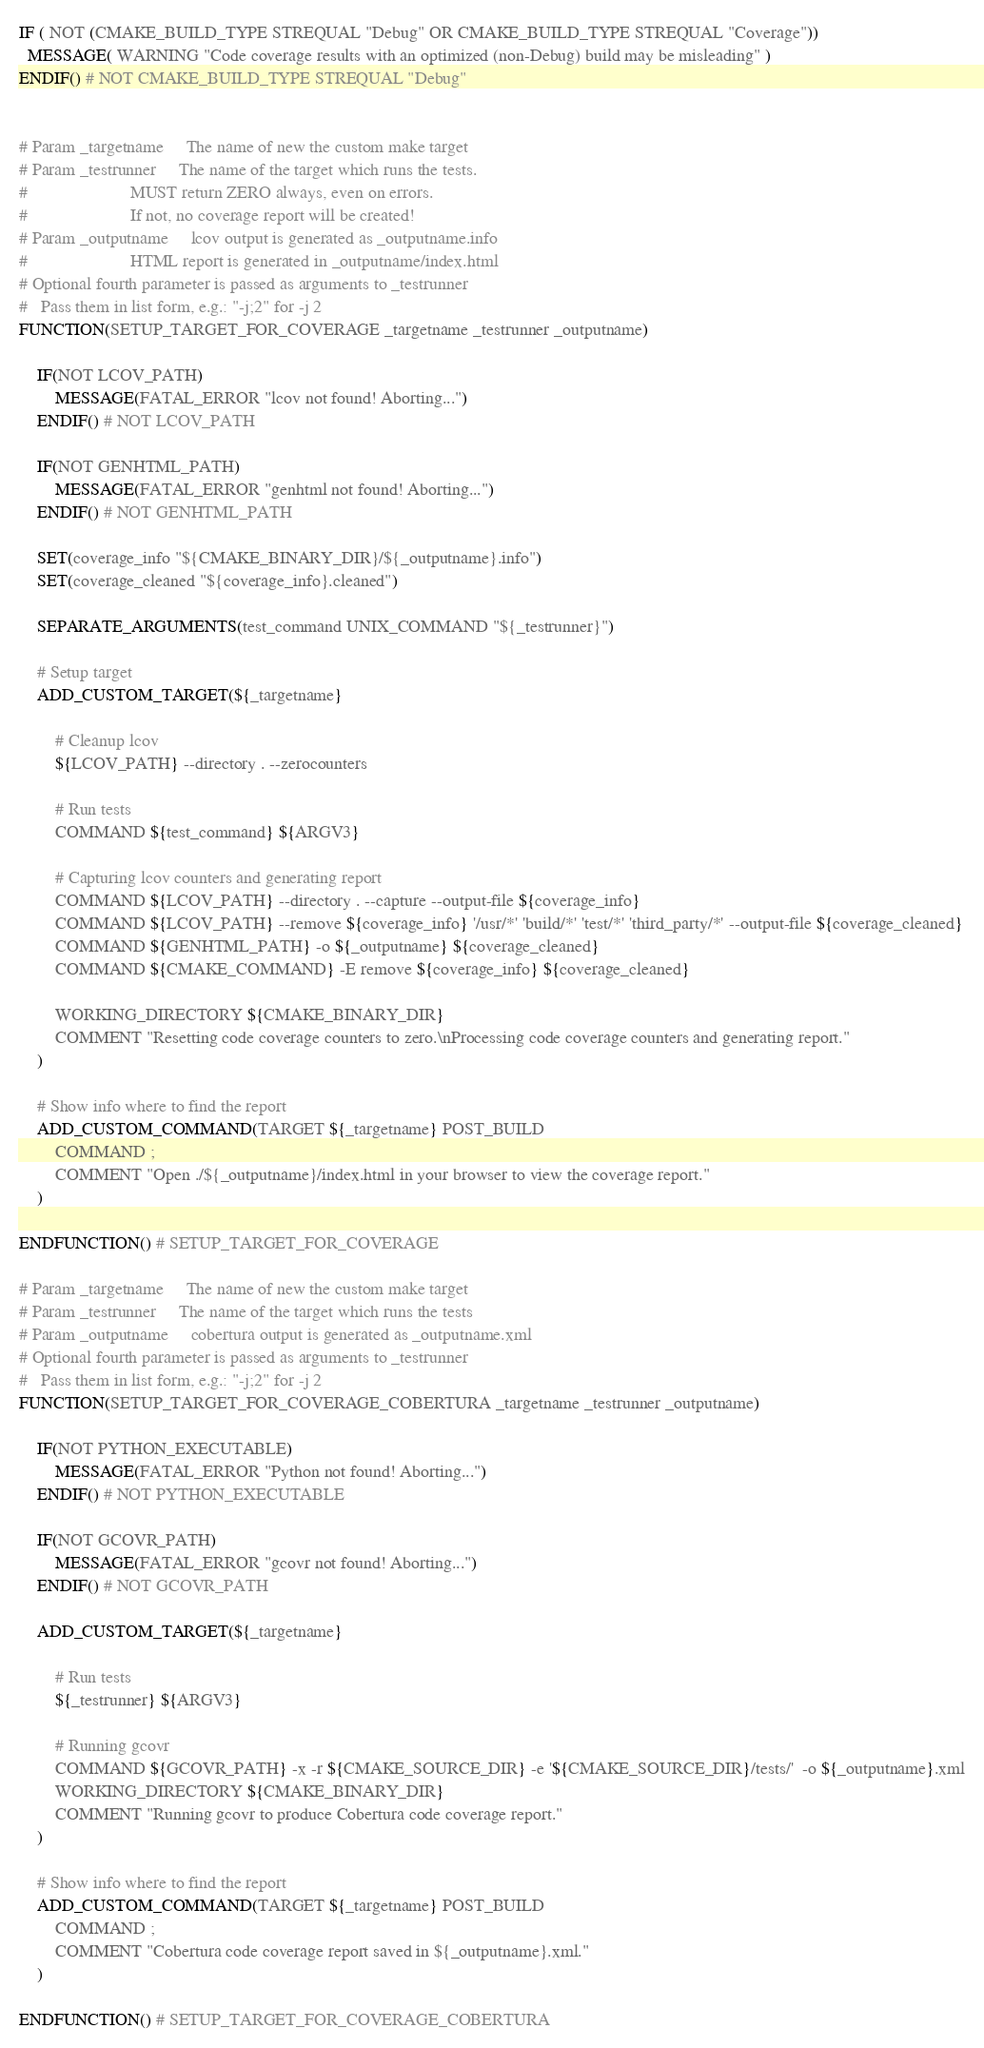Convert code to text. <code><loc_0><loc_0><loc_500><loc_500><_CMake_>
IF ( NOT (CMAKE_BUILD_TYPE STREQUAL "Debug" OR CMAKE_BUILD_TYPE STREQUAL "Coverage"))
  MESSAGE( WARNING "Code coverage results with an optimized (non-Debug) build may be misleading" )
ENDIF() # NOT CMAKE_BUILD_TYPE STREQUAL "Debug"


# Param _targetname     The name of new the custom make target
# Param _testrunner     The name of the target which runs the tests.
#						MUST return ZERO always, even on errors.
#						If not, no coverage report will be created!
# Param _outputname     lcov output is generated as _outputname.info
#                       HTML report is generated in _outputname/index.html
# Optional fourth parameter is passed as arguments to _testrunner
#   Pass them in list form, e.g.: "-j;2" for -j 2
FUNCTION(SETUP_TARGET_FOR_COVERAGE _targetname _testrunner _outputname)

	IF(NOT LCOV_PATH)
		MESSAGE(FATAL_ERROR "lcov not found! Aborting...")
	ENDIF() # NOT LCOV_PATH

	IF(NOT GENHTML_PATH)
		MESSAGE(FATAL_ERROR "genhtml not found! Aborting...")
	ENDIF() # NOT GENHTML_PATH

	SET(coverage_info "${CMAKE_BINARY_DIR}/${_outputname}.info")
	SET(coverage_cleaned "${coverage_info}.cleaned")

	SEPARATE_ARGUMENTS(test_command UNIX_COMMAND "${_testrunner}")

	# Setup target
	ADD_CUSTOM_TARGET(${_targetname}

		# Cleanup lcov
		${LCOV_PATH} --directory . --zerocounters

		# Run tests
		COMMAND ${test_command} ${ARGV3}

		# Capturing lcov counters and generating report
		COMMAND ${LCOV_PATH} --directory . --capture --output-file ${coverage_info}
		COMMAND ${LCOV_PATH} --remove ${coverage_info} '/usr/*' 'build/*' 'test/*' 'third_party/*' --output-file ${coverage_cleaned}
		COMMAND ${GENHTML_PATH} -o ${_outputname} ${coverage_cleaned}
		COMMAND ${CMAKE_COMMAND} -E remove ${coverage_info} ${coverage_cleaned}

		WORKING_DIRECTORY ${CMAKE_BINARY_DIR}
		COMMENT "Resetting code coverage counters to zero.\nProcessing code coverage counters and generating report."
	)

	# Show info where to find the report
	ADD_CUSTOM_COMMAND(TARGET ${_targetname} POST_BUILD
		COMMAND ;
		COMMENT "Open ./${_outputname}/index.html in your browser to view the coverage report."
	)

ENDFUNCTION() # SETUP_TARGET_FOR_COVERAGE

# Param _targetname     The name of new the custom make target
# Param _testrunner     The name of the target which runs the tests
# Param _outputname     cobertura output is generated as _outputname.xml
# Optional fourth parameter is passed as arguments to _testrunner
#   Pass them in list form, e.g.: "-j;2" for -j 2
FUNCTION(SETUP_TARGET_FOR_COVERAGE_COBERTURA _targetname _testrunner _outputname)

	IF(NOT PYTHON_EXECUTABLE)
		MESSAGE(FATAL_ERROR "Python not found! Aborting...")
	ENDIF() # NOT PYTHON_EXECUTABLE

	IF(NOT GCOVR_PATH)
		MESSAGE(FATAL_ERROR "gcovr not found! Aborting...")
	ENDIF() # NOT GCOVR_PATH

	ADD_CUSTOM_TARGET(${_targetname}

		# Run tests
		${_testrunner} ${ARGV3}

		# Running gcovr
		COMMAND ${GCOVR_PATH} -x -r ${CMAKE_SOURCE_DIR} -e '${CMAKE_SOURCE_DIR}/tests/'  -o ${_outputname}.xml
		WORKING_DIRECTORY ${CMAKE_BINARY_DIR}
		COMMENT "Running gcovr to produce Cobertura code coverage report."
	)

	# Show info where to find the report
	ADD_CUSTOM_COMMAND(TARGET ${_targetname} POST_BUILD
		COMMAND ;
		COMMENT "Cobertura code coverage report saved in ${_outputname}.xml."
	)

ENDFUNCTION() # SETUP_TARGET_FOR_COVERAGE_COBERTURA
</code> 